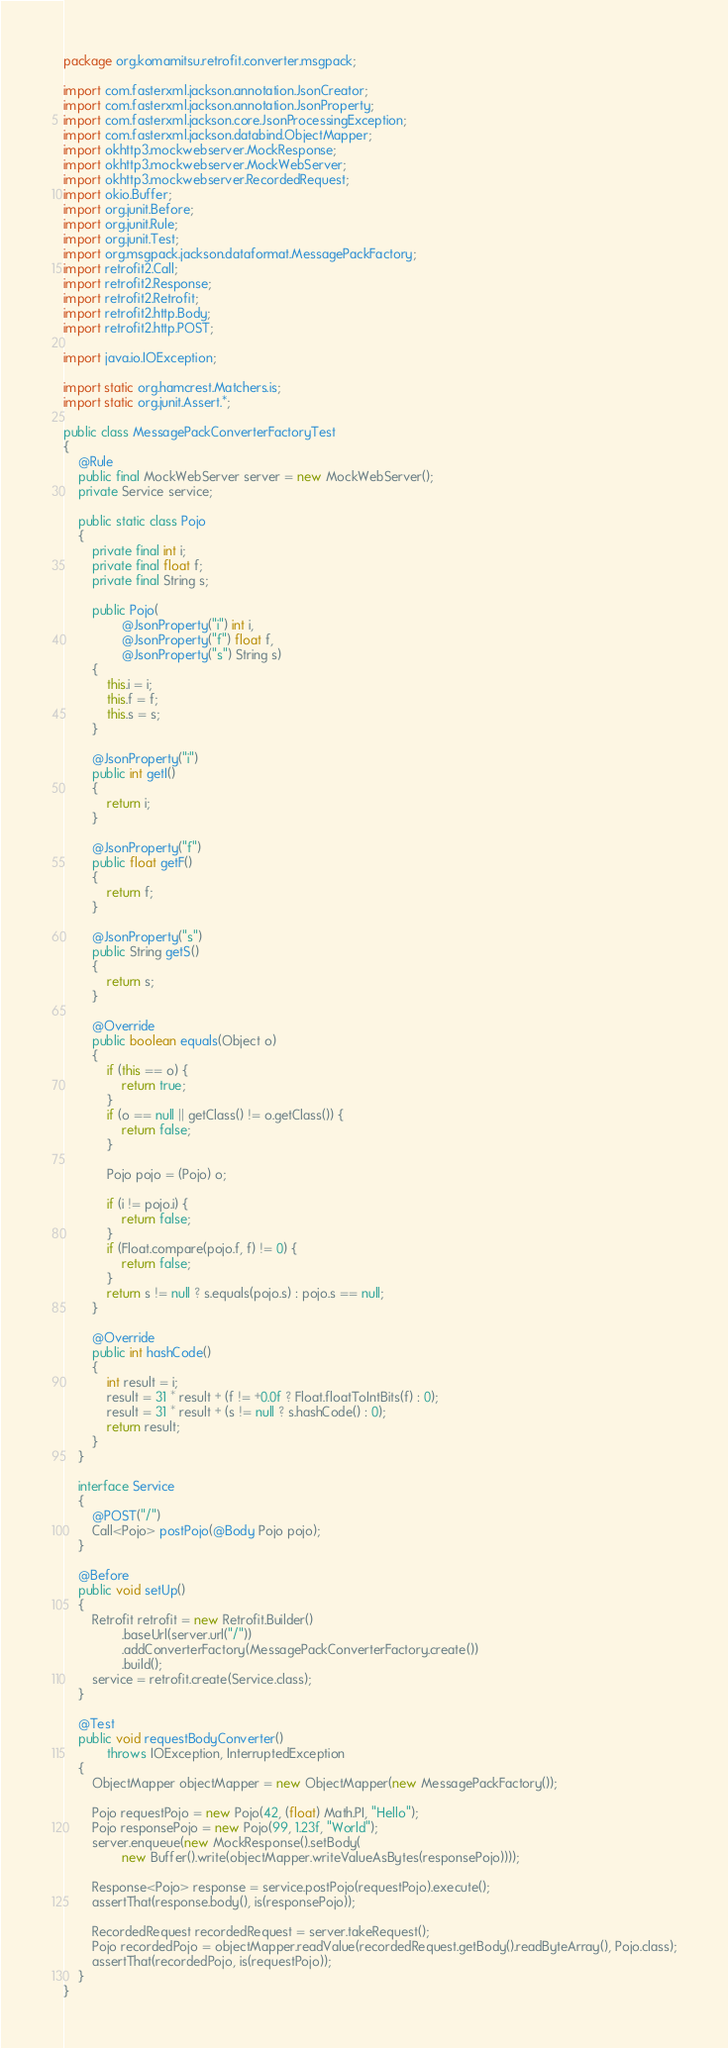<code> <loc_0><loc_0><loc_500><loc_500><_Java_>package org.komamitsu.retrofit.converter.msgpack;

import com.fasterxml.jackson.annotation.JsonCreator;
import com.fasterxml.jackson.annotation.JsonProperty;
import com.fasterxml.jackson.core.JsonProcessingException;
import com.fasterxml.jackson.databind.ObjectMapper;
import okhttp3.mockwebserver.MockResponse;
import okhttp3.mockwebserver.MockWebServer;
import okhttp3.mockwebserver.RecordedRequest;
import okio.Buffer;
import org.junit.Before;
import org.junit.Rule;
import org.junit.Test;
import org.msgpack.jackson.dataformat.MessagePackFactory;
import retrofit2.Call;
import retrofit2.Response;
import retrofit2.Retrofit;
import retrofit2.http.Body;
import retrofit2.http.POST;

import java.io.IOException;

import static org.hamcrest.Matchers.is;
import static org.junit.Assert.*;

public class MessagePackConverterFactoryTest
{
    @Rule
    public final MockWebServer server = new MockWebServer();
    private Service service;

    public static class Pojo
    {
        private final int i;
        private final float f;
        private final String s;

        public Pojo(
                @JsonProperty("i") int i,
                @JsonProperty("f") float f,
                @JsonProperty("s") String s)
        {
            this.i = i;
            this.f = f;
            this.s = s;
        }

        @JsonProperty("i")
        public int getI()
        {
            return i;
        }

        @JsonProperty("f")
        public float getF()
        {
            return f;
        }

        @JsonProperty("s")
        public String getS()
        {
            return s;
        }

        @Override
        public boolean equals(Object o)
        {
            if (this == o) {
                return true;
            }
            if (o == null || getClass() != o.getClass()) {
                return false;
            }

            Pojo pojo = (Pojo) o;

            if (i != pojo.i) {
                return false;
            }
            if (Float.compare(pojo.f, f) != 0) {
                return false;
            }
            return s != null ? s.equals(pojo.s) : pojo.s == null;
        }

        @Override
        public int hashCode()
        {
            int result = i;
            result = 31 * result + (f != +0.0f ? Float.floatToIntBits(f) : 0);
            result = 31 * result + (s != null ? s.hashCode() : 0);
            return result;
        }
    }

    interface Service
    {
        @POST("/")
        Call<Pojo> postPojo(@Body Pojo pojo);
    }

    @Before
    public void setUp()
    {
        Retrofit retrofit = new Retrofit.Builder()
                .baseUrl(server.url("/"))
                .addConverterFactory(MessagePackConverterFactory.create())
                .build();
        service = retrofit.create(Service.class);
    }

    @Test
    public void requestBodyConverter()
            throws IOException, InterruptedException
    {
        ObjectMapper objectMapper = new ObjectMapper(new MessagePackFactory());

        Pojo requestPojo = new Pojo(42, (float) Math.PI, "Hello");
        Pojo responsePojo = new Pojo(99, 1.23f, "World");
        server.enqueue(new MockResponse().setBody(
                new Buffer().write(objectMapper.writeValueAsBytes(responsePojo))));

        Response<Pojo> response = service.postPojo(requestPojo).execute();
        assertThat(response.body(), is(responsePojo));

        RecordedRequest recordedRequest = server.takeRequest();
        Pojo recordedPojo = objectMapper.readValue(recordedRequest.getBody().readByteArray(), Pojo.class);
        assertThat(recordedPojo, is(requestPojo));
    }
}
</code> 